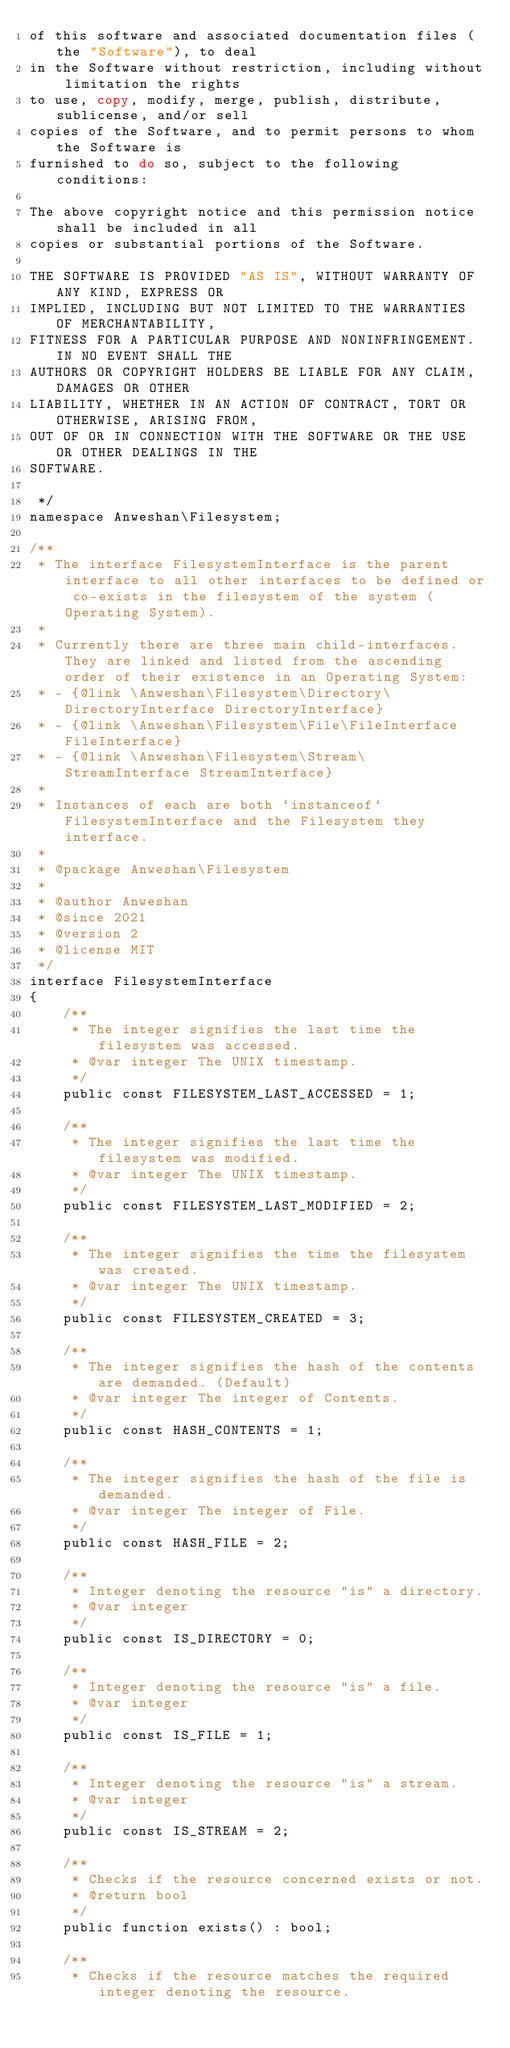Convert code to text. <code><loc_0><loc_0><loc_500><loc_500><_PHP_>of this software and associated documentation files (the "Software"), to deal
in the Software without restriction, including without limitation the rights
to use, copy, modify, merge, publish, distribute, sublicense, and/or sell
copies of the Software, and to permit persons to whom the Software is
furnished to do so, subject to the following conditions:

The above copyright notice and this permission notice shall be included in all
copies or substantial portions of the Software.

THE SOFTWARE IS PROVIDED "AS IS", WITHOUT WARRANTY OF ANY KIND, EXPRESS OR
IMPLIED, INCLUDING BUT NOT LIMITED TO THE WARRANTIES OF MERCHANTABILITY,
FITNESS FOR A PARTICULAR PURPOSE AND NONINFRINGEMENT. IN NO EVENT SHALL THE
AUTHORS OR COPYRIGHT HOLDERS BE LIABLE FOR ANY CLAIM, DAMAGES OR OTHER
LIABILITY, WHETHER IN AN ACTION OF CONTRACT, TORT OR OTHERWISE, ARISING FROM,
OUT OF OR IN CONNECTION WITH THE SOFTWARE OR THE USE OR OTHER DEALINGS IN THE
SOFTWARE.

 */
namespace Anweshan\Filesystem;

/**
 * The interface FilesystemInterface is the parent interface to all other interfaces to be defined or co-exists in the filesystem of the system (Operating System).
 *
 * Currently there are three main child-interfaces. They are linked and listed from the ascending order of their existence in an Operating System:
 * - {@link \Anweshan\Filesystem\Directory\DirectoryInterface DirectoryInterface}
 * - {@link \Anweshan\Filesystem\File\FileInterface FileInterface}
 * - {@link \Anweshan\Filesystem\Stream\StreamInterface StreamInterface}
 *
 * Instances of each are both `instanceof` FilesystemInterface and the Filesystem they interface.
 *
 * @package Anweshan\Filesystem
 *
 * @author Anweshan
 * @since 2021
 * @version 2
 * @license MIT
 */
interface FilesystemInterface
{
    /**
     * The integer signifies the last time the filesystem was accessed.
     * @var integer The UNIX timestamp.
     */
    public const FILESYSTEM_LAST_ACCESSED = 1;

    /**
     * The integer signifies the last time the filesystem was modified.
     * @var integer The UNIX timestamp.
     */
    public const FILESYSTEM_LAST_MODIFIED = 2;

    /**
     * The integer signifies the time the filesystem was created.
     * @var integer The UNIX timestamp.
     */
    public const FILESYSTEM_CREATED = 3;

    /**
     * The integer signifies the hash of the contents are demanded. (Default)
     * @var integer The integer of Contents.
     */
    public const HASH_CONTENTS = 1;

    /**
     * The integer signifies the hash of the file is demanded.
     * @var integer The integer of File.
     */
    public const HASH_FILE = 2;

    /**
     * Integer denoting the resource "is" a directory.
     * @var integer
     */
    public const IS_DIRECTORY = 0;
    
    /**
     * Integer denoting the resource "is" a file.
     * @var integer
     */
    public const IS_FILE = 1;
    
    /**
     * Integer denoting the resource "is" a stream.
     * @var integer
     */
    public const IS_STREAM = 2;
    
    /**
     * Checks if the resource concerned exists or not.
     * @return bool
     */
    public function exists() : bool;
    
    /**
     * Checks if the resource matches the required integer denoting the resource.</code> 